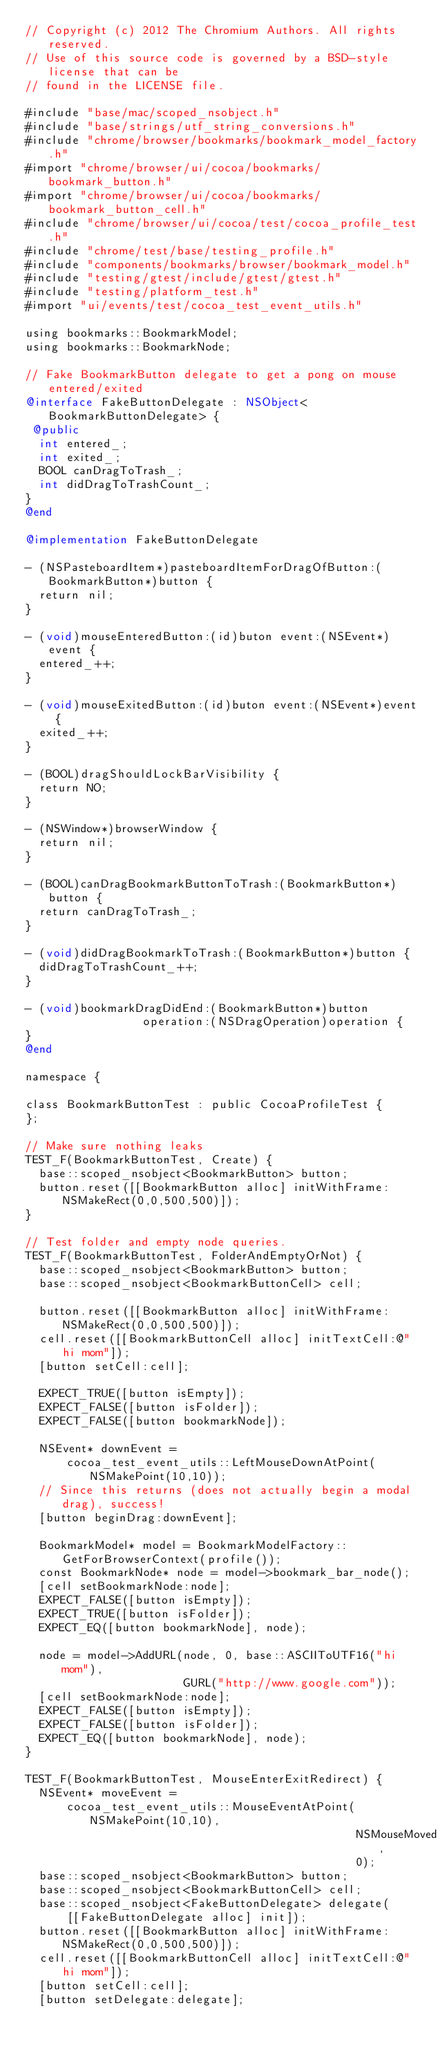Convert code to text. <code><loc_0><loc_0><loc_500><loc_500><_ObjectiveC_>// Copyright (c) 2012 The Chromium Authors. All rights reserved.
// Use of this source code is governed by a BSD-style license that can be
// found in the LICENSE file.

#include "base/mac/scoped_nsobject.h"
#include "base/strings/utf_string_conversions.h"
#include "chrome/browser/bookmarks/bookmark_model_factory.h"
#import "chrome/browser/ui/cocoa/bookmarks/bookmark_button.h"
#import "chrome/browser/ui/cocoa/bookmarks/bookmark_button_cell.h"
#include "chrome/browser/ui/cocoa/test/cocoa_profile_test.h"
#include "chrome/test/base/testing_profile.h"
#include "components/bookmarks/browser/bookmark_model.h"
#include "testing/gtest/include/gtest/gtest.h"
#include "testing/platform_test.h"
#import "ui/events/test/cocoa_test_event_utils.h"

using bookmarks::BookmarkModel;
using bookmarks::BookmarkNode;

// Fake BookmarkButton delegate to get a pong on mouse entered/exited
@interface FakeButtonDelegate : NSObject<BookmarkButtonDelegate> {
 @public
  int entered_;
  int exited_;
  BOOL canDragToTrash_;
  int didDragToTrashCount_;
}
@end

@implementation FakeButtonDelegate

- (NSPasteboardItem*)pasteboardItemForDragOfButton:(BookmarkButton*)button {
  return nil;
}

- (void)mouseEnteredButton:(id)buton event:(NSEvent*)event {
  entered_++;
}

- (void)mouseExitedButton:(id)buton event:(NSEvent*)event {
  exited_++;
}

- (BOOL)dragShouldLockBarVisibility {
  return NO;
}

- (NSWindow*)browserWindow {
  return nil;
}

- (BOOL)canDragBookmarkButtonToTrash:(BookmarkButton*)button {
  return canDragToTrash_;
}

- (void)didDragBookmarkToTrash:(BookmarkButton*)button {
  didDragToTrashCount_++;
}

- (void)bookmarkDragDidEnd:(BookmarkButton*)button
                 operation:(NSDragOperation)operation {
}
@end

namespace {

class BookmarkButtonTest : public CocoaProfileTest {
};

// Make sure nothing leaks
TEST_F(BookmarkButtonTest, Create) {
  base::scoped_nsobject<BookmarkButton> button;
  button.reset([[BookmarkButton alloc] initWithFrame:NSMakeRect(0,0,500,500)]);
}

// Test folder and empty node queries.
TEST_F(BookmarkButtonTest, FolderAndEmptyOrNot) {
  base::scoped_nsobject<BookmarkButton> button;
  base::scoped_nsobject<BookmarkButtonCell> cell;

  button.reset([[BookmarkButton alloc] initWithFrame:NSMakeRect(0,0,500,500)]);
  cell.reset([[BookmarkButtonCell alloc] initTextCell:@"hi mom"]);
  [button setCell:cell];

  EXPECT_TRUE([button isEmpty]);
  EXPECT_FALSE([button isFolder]);
  EXPECT_FALSE([button bookmarkNode]);

  NSEvent* downEvent =
      cocoa_test_event_utils::LeftMouseDownAtPoint(NSMakePoint(10,10));
  // Since this returns (does not actually begin a modal drag), success!
  [button beginDrag:downEvent];

  BookmarkModel* model = BookmarkModelFactory::GetForBrowserContext(profile());
  const BookmarkNode* node = model->bookmark_bar_node();
  [cell setBookmarkNode:node];
  EXPECT_FALSE([button isEmpty]);
  EXPECT_TRUE([button isFolder]);
  EXPECT_EQ([button bookmarkNode], node);

  node = model->AddURL(node, 0, base::ASCIIToUTF16("hi mom"),
                       GURL("http://www.google.com"));
  [cell setBookmarkNode:node];
  EXPECT_FALSE([button isEmpty]);
  EXPECT_FALSE([button isFolder]);
  EXPECT_EQ([button bookmarkNode], node);
}

TEST_F(BookmarkButtonTest, MouseEnterExitRedirect) {
  NSEvent* moveEvent =
      cocoa_test_event_utils::MouseEventAtPoint(NSMakePoint(10,10),
                                                NSMouseMoved,
                                                0);
  base::scoped_nsobject<BookmarkButton> button;
  base::scoped_nsobject<BookmarkButtonCell> cell;
  base::scoped_nsobject<FakeButtonDelegate> delegate(
      [[FakeButtonDelegate alloc] init]);
  button.reset([[BookmarkButton alloc] initWithFrame:NSMakeRect(0,0,500,500)]);
  cell.reset([[BookmarkButtonCell alloc] initTextCell:@"hi mom"]);
  [button setCell:cell];
  [button setDelegate:delegate];
</code> 